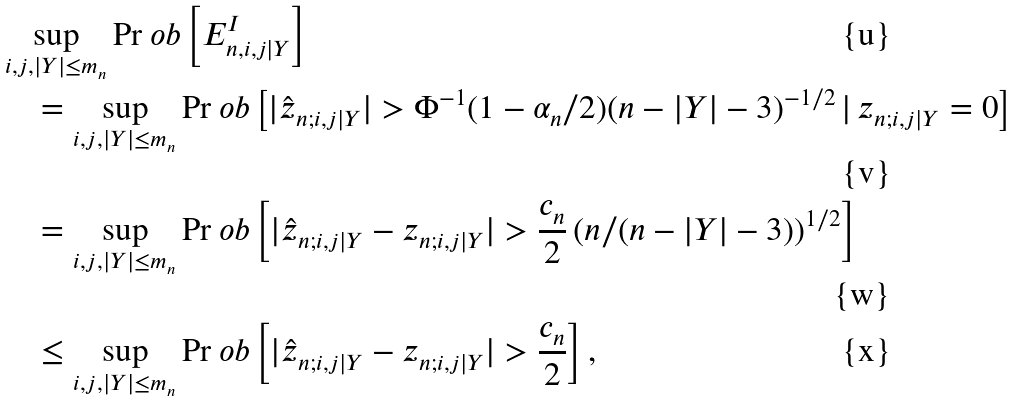Convert formula to latex. <formula><loc_0><loc_0><loc_500><loc_500>& \sup _ { i , j , | Y | \leq m _ { n } } \Pr o b \left [ E ^ { I } _ { n , i , j | Y } \right ] \\ & \quad = \sup _ { i , j , | Y | \leq m _ { n } } \Pr o b \left [ | \hat { z } _ { n ; i , j | Y } | > \Phi ^ { - 1 } ( 1 - \alpha _ { n } / 2 ) ( n - | Y | - 3 ) ^ { - 1 / 2 } \, | \, z _ { n ; i , j | Y } = 0 \right ] \\ & \quad = \sup _ { i , j , | Y | \leq m _ { n } } \Pr o b \left [ | \hat { z } _ { n ; i , j | Y } - z _ { n ; i , j | Y } | > \frac { c _ { n } } { 2 } \left ( n / ( n - | Y | - 3 ) \right ) ^ { 1 / 2 } \right ] \\ & \quad \leq \sup _ { i , j , | Y | \leq m _ { n } } \Pr o b \left [ | \hat { z } _ { n ; i , j | Y } - z _ { n ; i , j | Y } | > \frac { c _ { n } } { 2 } \right ] ,</formula> 